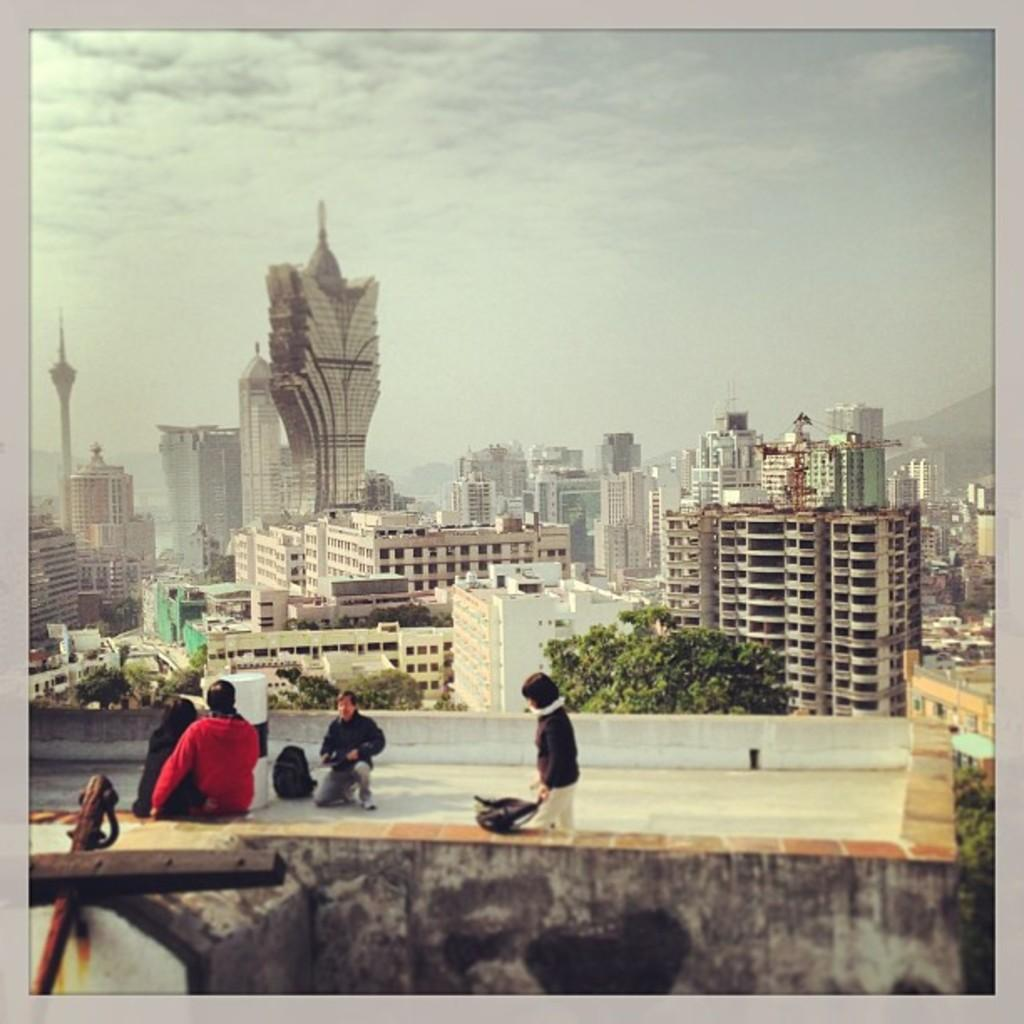Where are the people located in the image? The people are on the terrace of a building. What can be seen in the image besides the people on the terrace? There are trees visible in the image. What is located at the back of the image? There are many buildings at the back. What is visible at the top of the image? The sky is visible at the top of the image. How many pins are holding the goat in the image? There is no goat present in the image, and therefore no pins holding it. 